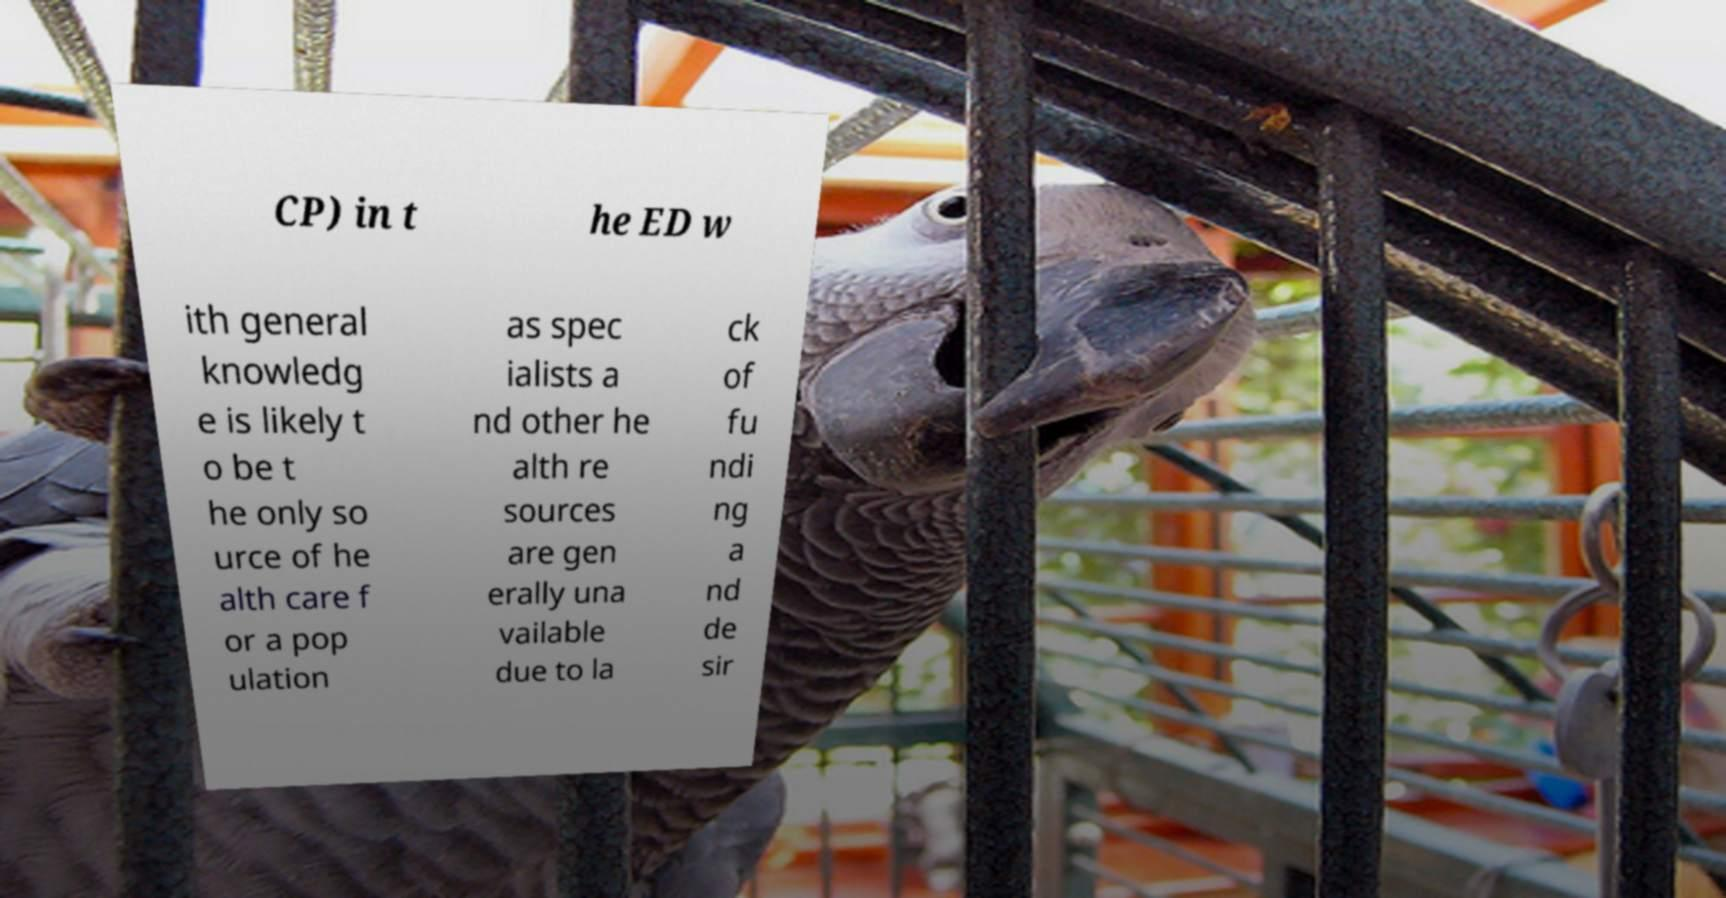Could you extract and type out the text from this image? CP) in t he ED w ith general knowledg e is likely t o be t he only so urce of he alth care f or a pop ulation as spec ialists a nd other he alth re sources are gen erally una vailable due to la ck of fu ndi ng a nd de sir 